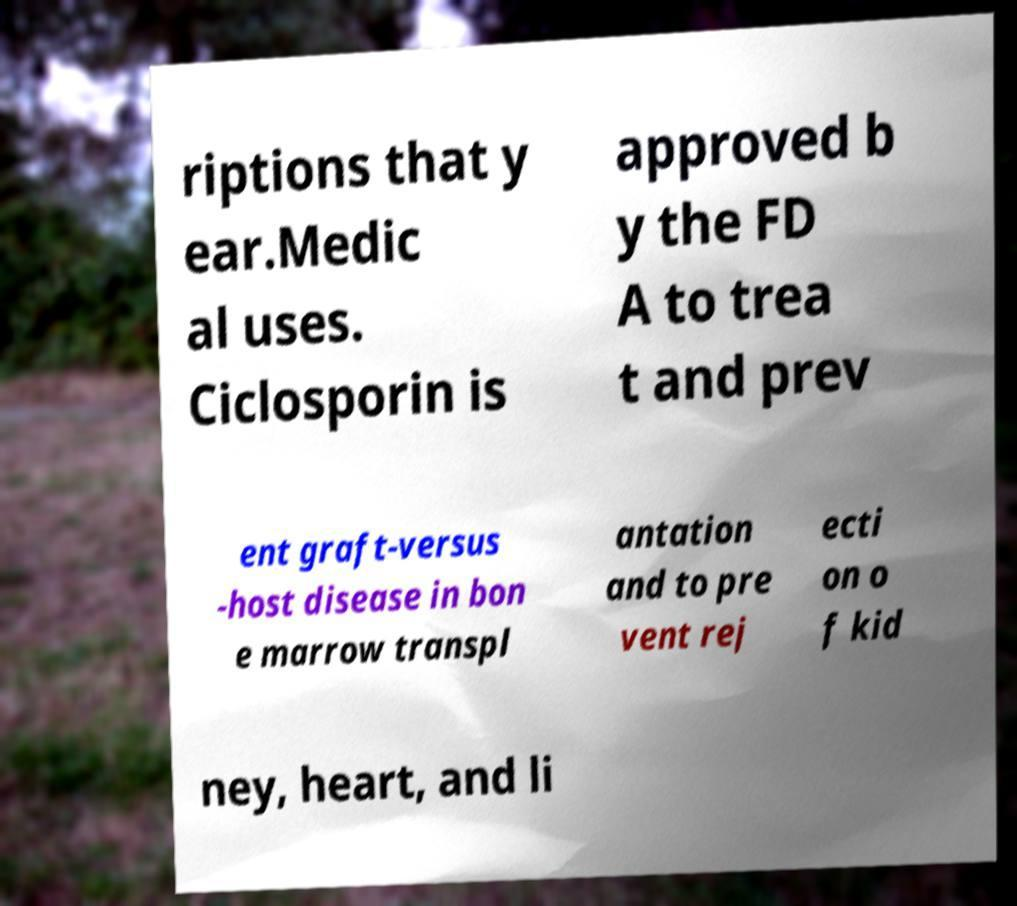There's text embedded in this image that I need extracted. Can you transcribe it verbatim? riptions that y ear.Medic al uses. Ciclosporin is approved b y the FD A to trea t and prev ent graft-versus -host disease in bon e marrow transpl antation and to pre vent rej ecti on o f kid ney, heart, and li 